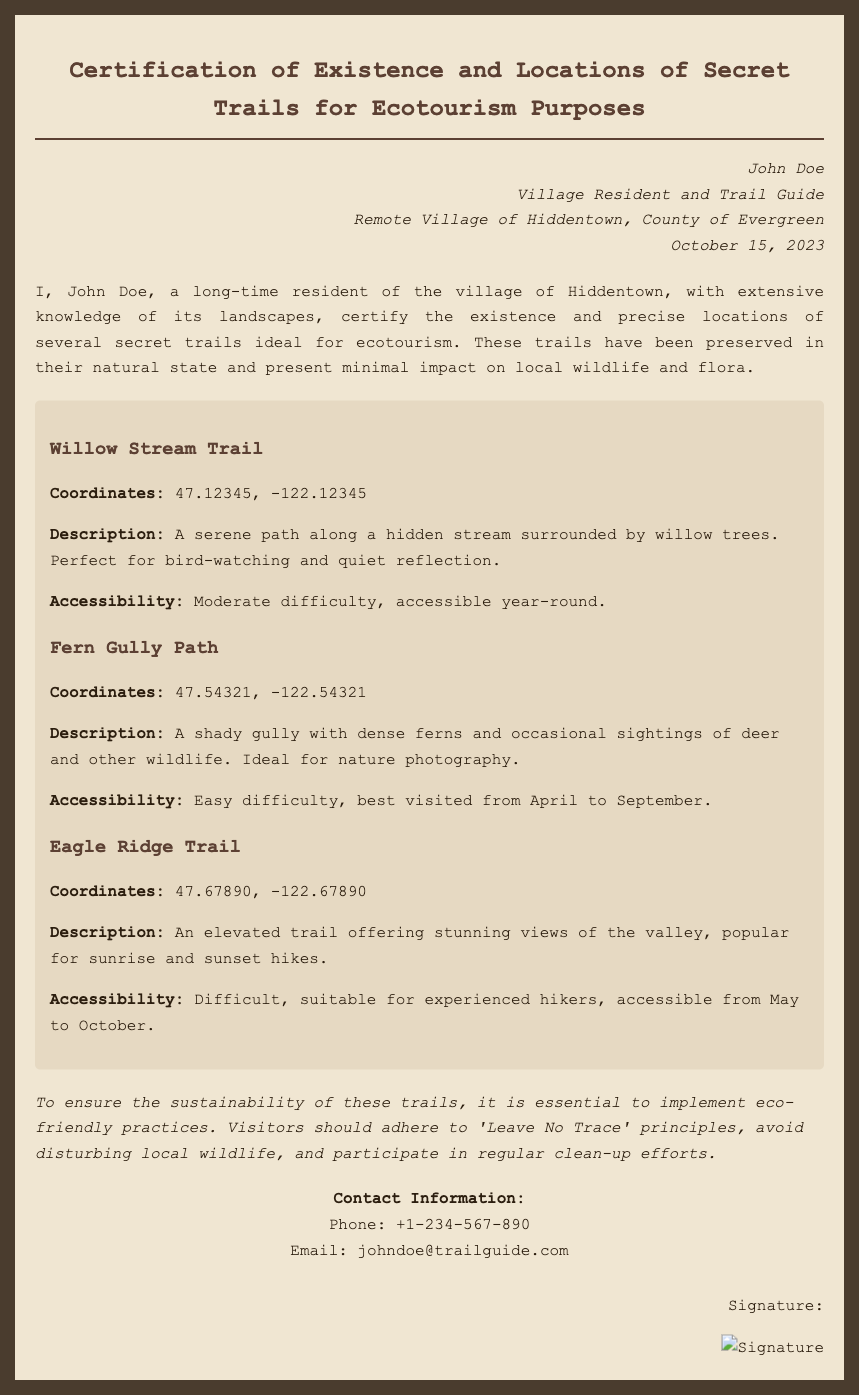What is the name of the issuer? The issuer of the document is the person who certified the trails, as stated at the top of the document.
Answer: John Doe When was the certification signed? The certification includes a date of signing that signifies when the document was officially completed.
Answer: October 15, 2023 What is the first trail listed? The trails are organized with titles and descriptions that allow for easy identification.
Answer: Willow Stream Trail What is the difficulty level of the Eagle Ridge Trail? Each trail description includes an accessibility section indicating the difficulty level of the trail.
Answer: Difficult What are visitors encouraged to follow to ensure sustainability? The document advises on eco-friendly practices that visitors should implement while exploring the trails.
Answer: Leave No Trace principles How many trails are certified in the document? The number of trails can be counted based on the listings within the trails section of the document.
Answer: Three What is the contact email provided in the document? The contact information section reveals how to reach the issuer for further inquiries.
Answer: johndoe@trailguide.com What is the main purpose of the certification? The overall objective of the document can be understood from the title and statements included within it.
Answer: Ecotourism purposes What type of report is this document categorized as? The document's title describes its nature, highlighting its formal declaration about specific trails.
Answer: Certification 